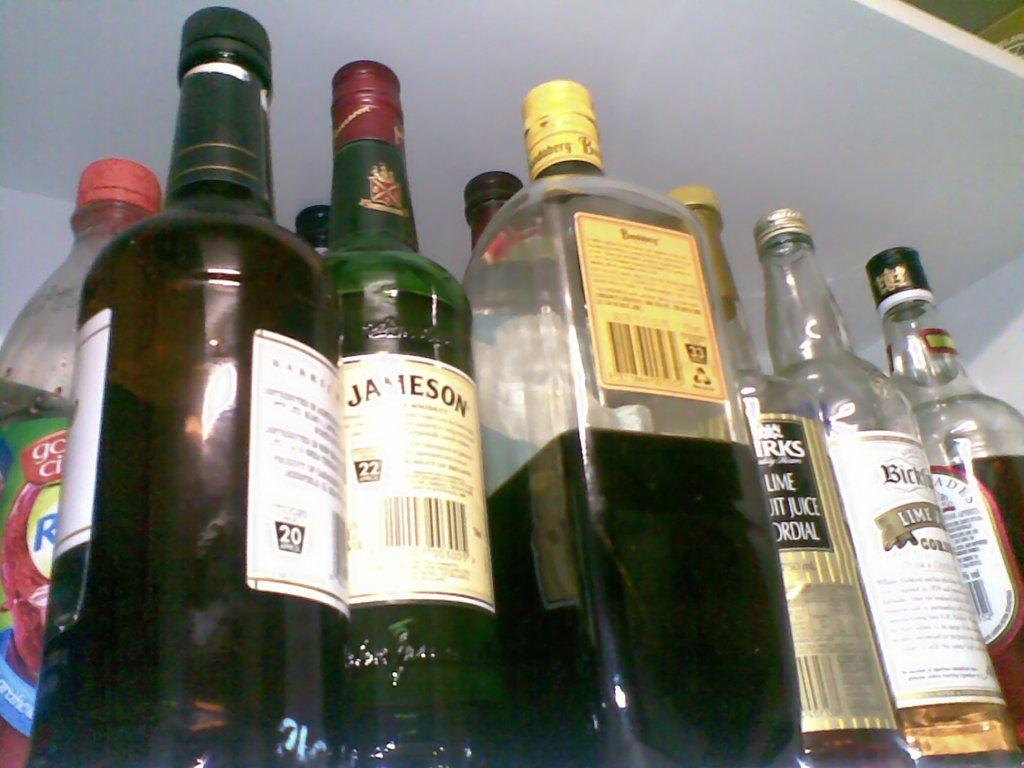What is the main subject of the image? The main subject of the image is a group of wine bottles. Can you describe the appearance of the wine bottles? The wine bottles have labels on them. What type of thunder can be heard in the background of the image? There is no thunder present in the image, as it features a group of wine bottles with labels. 